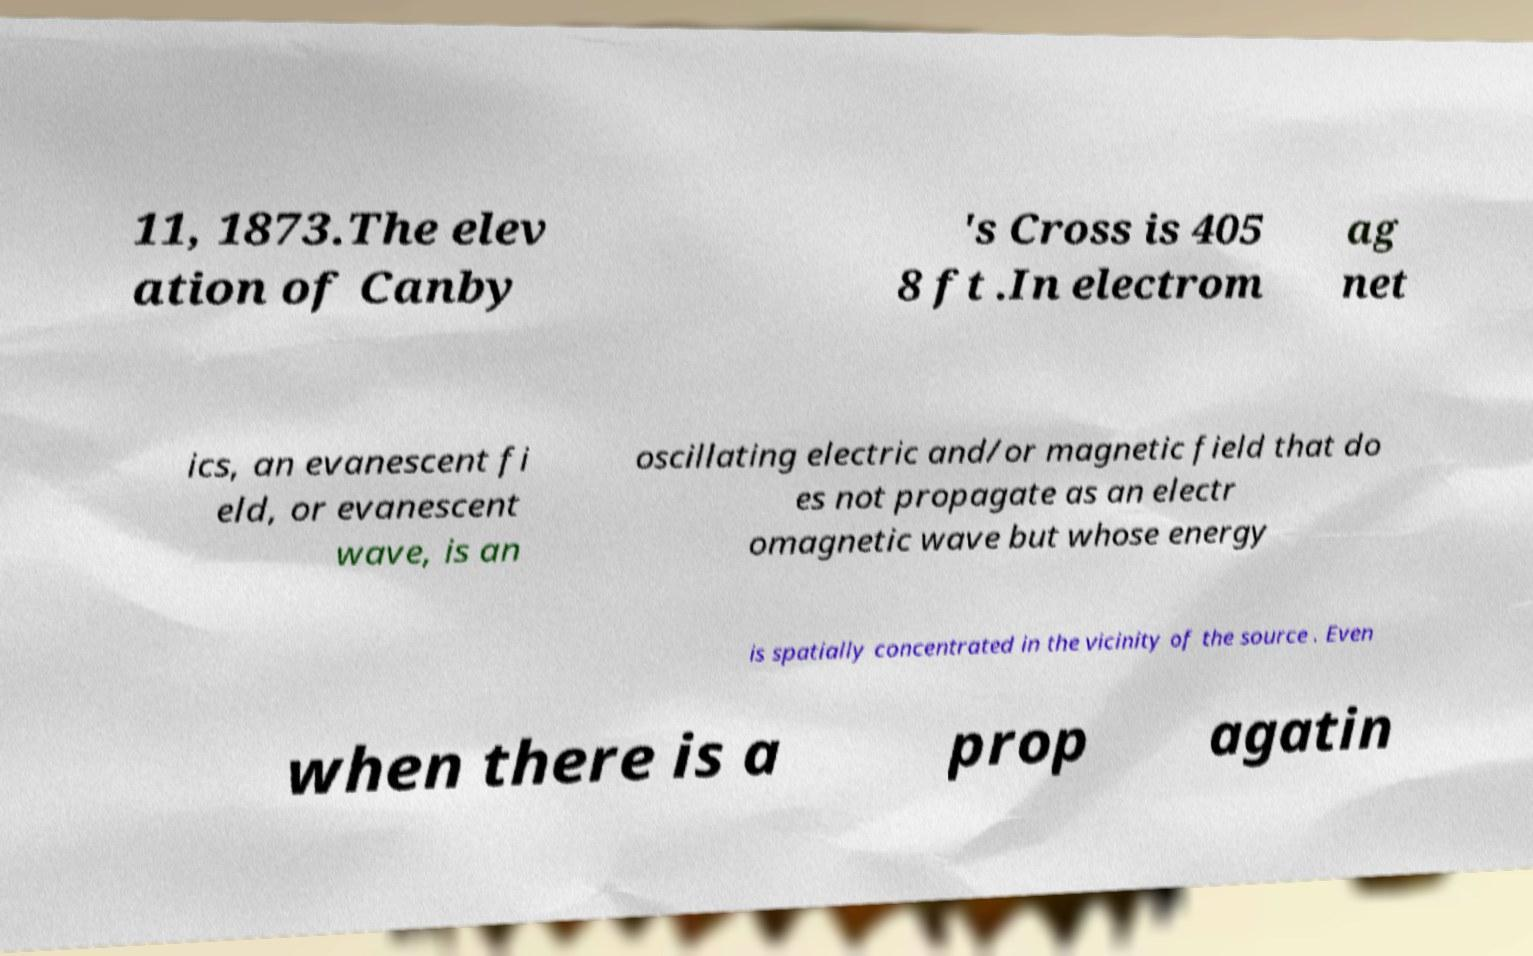Please identify and transcribe the text found in this image. 11, 1873.The elev ation of Canby 's Cross is 405 8 ft .In electrom ag net ics, an evanescent fi eld, or evanescent wave, is an oscillating electric and/or magnetic field that do es not propagate as an electr omagnetic wave but whose energy is spatially concentrated in the vicinity of the source . Even when there is a prop agatin 